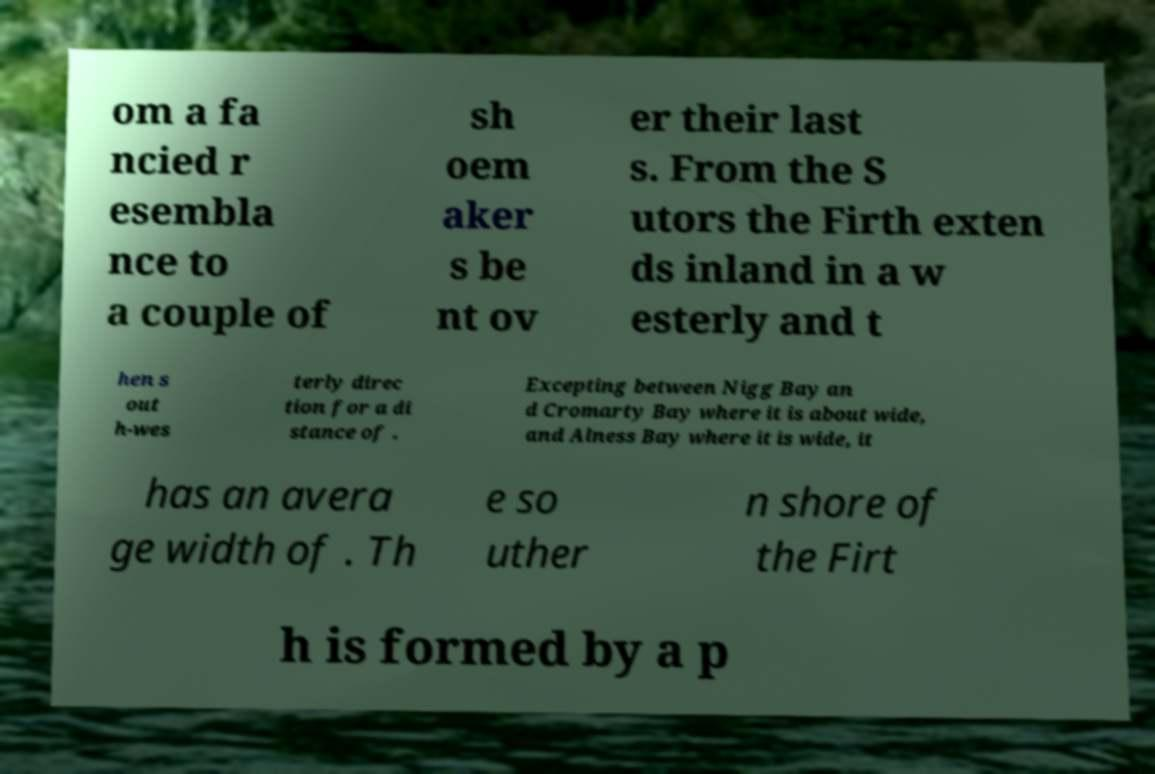Can you accurately transcribe the text from the provided image for me? om a fa ncied r esembla nce to a couple of sh oem aker s be nt ov er their last s. From the S utors the Firth exten ds inland in a w esterly and t hen s out h-wes terly direc tion for a di stance of . Excepting between Nigg Bay an d Cromarty Bay where it is about wide, and Alness Bay where it is wide, it has an avera ge width of . Th e so uther n shore of the Firt h is formed by a p 